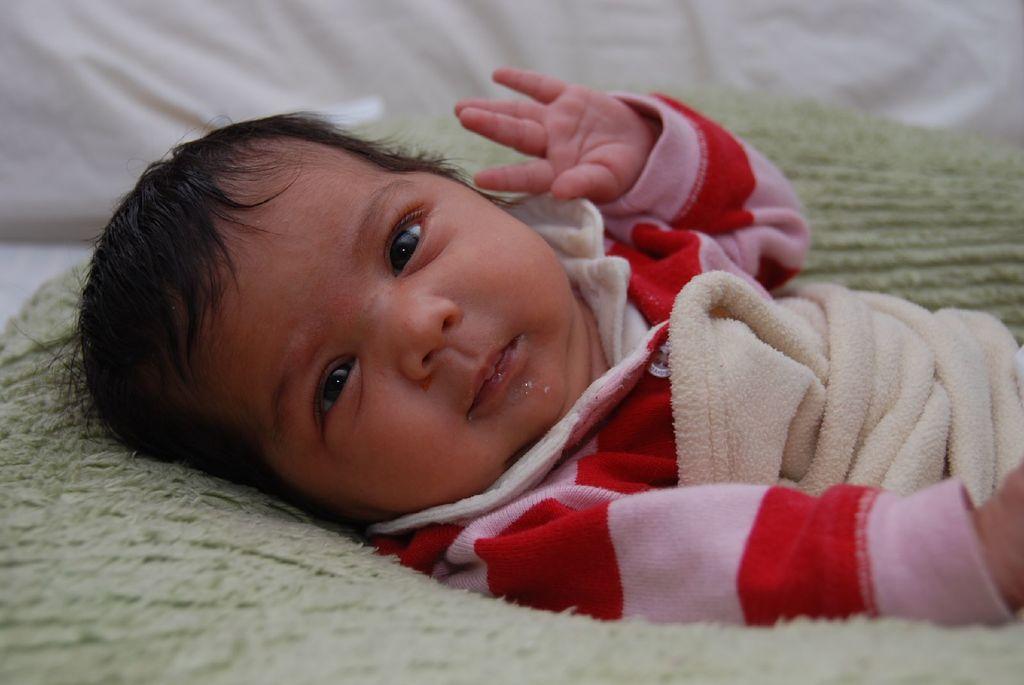Describe this image in one or two sentences. In this picture we can see the small baby wearing pink and red color dress, lying on the bed and looking to the camera. Behind there is a white pillow. 